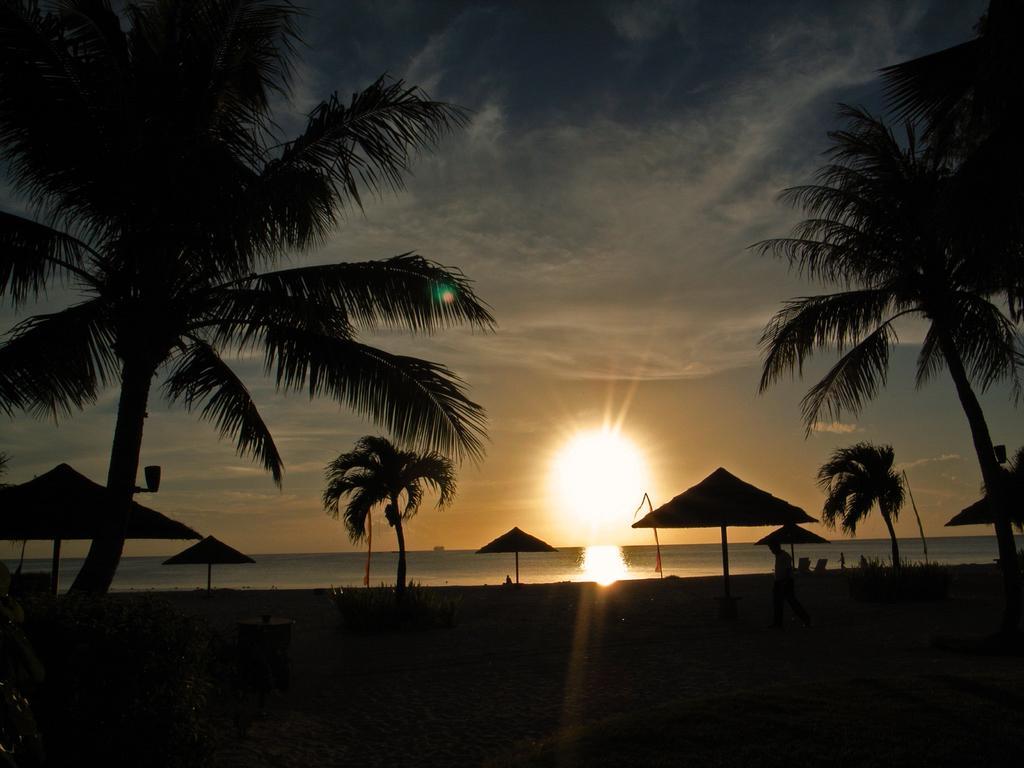How would you summarize this image in a sentence or two? In this image I see the trees, umbrellas and I see a person over here. In the background I see the water and the sun and I see that this picture is a bit dark. 